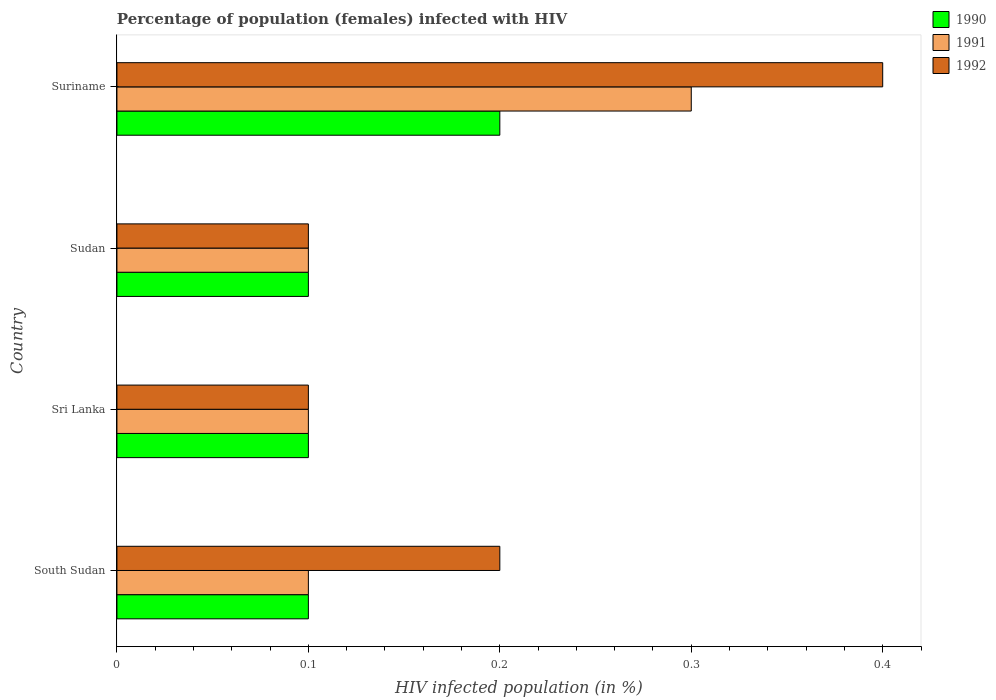Are the number of bars on each tick of the Y-axis equal?
Ensure brevity in your answer.  Yes. How many bars are there on the 2nd tick from the bottom?
Your answer should be very brief. 3. What is the label of the 3rd group of bars from the top?
Provide a short and direct response. Sri Lanka. In how many cases, is the number of bars for a given country not equal to the number of legend labels?
Ensure brevity in your answer.  0. Across all countries, what is the maximum percentage of HIV infected female population in 1991?
Offer a terse response. 0.3. In which country was the percentage of HIV infected female population in 1991 maximum?
Provide a short and direct response. Suriname. In which country was the percentage of HIV infected female population in 1992 minimum?
Keep it short and to the point. Sri Lanka. What is the total percentage of HIV infected female population in 1991 in the graph?
Your answer should be very brief. 0.6. What is the difference between the percentage of HIV infected female population in 1990 in Sri Lanka and the percentage of HIV infected female population in 1991 in Sudan?
Provide a succinct answer. 0. What is the difference between the highest and the second highest percentage of HIV infected female population in 1991?
Ensure brevity in your answer.  0.2. In how many countries, is the percentage of HIV infected female population in 1991 greater than the average percentage of HIV infected female population in 1991 taken over all countries?
Ensure brevity in your answer.  1. What does the 3rd bar from the top in South Sudan represents?
Ensure brevity in your answer.  1990. What does the 2nd bar from the bottom in South Sudan represents?
Ensure brevity in your answer.  1991. Are the values on the major ticks of X-axis written in scientific E-notation?
Offer a terse response. No. Does the graph contain any zero values?
Your answer should be compact. No. Where does the legend appear in the graph?
Offer a terse response. Top right. How many legend labels are there?
Offer a terse response. 3. What is the title of the graph?
Ensure brevity in your answer.  Percentage of population (females) infected with HIV. What is the label or title of the X-axis?
Make the answer very short. HIV infected population (in %). What is the label or title of the Y-axis?
Offer a terse response. Country. What is the HIV infected population (in %) of 1991 in South Sudan?
Your answer should be very brief. 0.1. What is the HIV infected population (in %) of 1992 in South Sudan?
Your response must be concise. 0.2. What is the HIV infected population (in %) in 1991 in Sri Lanka?
Keep it short and to the point. 0.1. What is the HIV infected population (in %) in 1990 in Sudan?
Keep it short and to the point. 0.1. What is the HIV infected population (in %) in 1991 in Sudan?
Provide a succinct answer. 0.1. What is the HIV infected population (in %) in 1992 in Sudan?
Offer a very short reply. 0.1. What is the HIV infected population (in %) in 1991 in Suriname?
Ensure brevity in your answer.  0.3. What is the HIV infected population (in %) of 1992 in Suriname?
Your response must be concise. 0.4. Across all countries, what is the maximum HIV infected population (in %) of 1992?
Keep it short and to the point. 0.4. Across all countries, what is the minimum HIV infected population (in %) in 1991?
Your answer should be very brief. 0.1. What is the total HIV infected population (in %) of 1990 in the graph?
Keep it short and to the point. 0.5. What is the total HIV infected population (in %) of 1992 in the graph?
Offer a terse response. 0.8. What is the difference between the HIV infected population (in %) of 1992 in South Sudan and that in Sri Lanka?
Offer a terse response. 0.1. What is the difference between the HIV infected population (in %) in 1990 in South Sudan and that in Sudan?
Your answer should be compact. 0. What is the difference between the HIV infected population (in %) of 1992 in South Sudan and that in Sudan?
Give a very brief answer. 0.1. What is the difference between the HIV infected population (in %) in 1990 in South Sudan and that in Suriname?
Make the answer very short. -0.1. What is the difference between the HIV infected population (in %) of 1990 in Sri Lanka and that in Sudan?
Provide a short and direct response. 0. What is the difference between the HIV infected population (in %) of 1992 in Sri Lanka and that in Sudan?
Your answer should be compact. 0. What is the difference between the HIV infected population (in %) in 1991 in Sri Lanka and that in Suriname?
Your answer should be very brief. -0.2. What is the difference between the HIV infected population (in %) in 1992 in Sri Lanka and that in Suriname?
Ensure brevity in your answer.  -0.3. What is the difference between the HIV infected population (in %) of 1990 in Sudan and that in Suriname?
Provide a succinct answer. -0.1. What is the difference between the HIV infected population (in %) of 1992 in Sudan and that in Suriname?
Offer a terse response. -0.3. What is the difference between the HIV infected population (in %) in 1990 in South Sudan and the HIV infected population (in %) in 1991 in Sudan?
Offer a terse response. 0. What is the difference between the HIV infected population (in %) of 1991 in South Sudan and the HIV infected population (in %) of 1992 in Sudan?
Give a very brief answer. 0. What is the difference between the HIV infected population (in %) of 1990 in South Sudan and the HIV infected population (in %) of 1991 in Suriname?
Provide a short and direct response. -0.2. What is the difference between the HIV infected population (in %) in 1990 in Sri Lanka and the HIV infected population (in %) in 1991 in Sudan?
Make the answer very short. 0. What is the difference between the HIV infected population (in %) of 1990 in Sri Lanka and the HIV infected population (in %) of 1992 in Sudan?
Provide a short and direct response. 0. What is the difference between the HIV infected population (in %) in 1991 in Sri Lanka and the HIV infected population (in %) in 1992 in Sudan?
Your answer should be compact. 0. What is the difference between the HIV infected population (in %) of 1990 in Sudan and the HIV infected population (in %) of 1991 in Suriname?
Your response must be concise. -0.2. What is the difference between the HIV infected population (in %) in 1990 in Sudan and the HIV infected population (in %) in 1992 in Suriname?
Your response must be concise. -0.3. What is the average HIV infected population (in %) in 1991 per country?
Keep it short and to the point. 0.15. What is the difference between the HIV infected population (in %) of 1990 and HIV infected population (in %) of 1991 in South Sudan?
Your response must be concise. 0. What is the difference between the HIV infected population (in %) in 1991 and HIV infected population (in %) in 1992 in South Sudan?
Offer a terse response. -0.1. What is the difference between the HIV infected population (in %) of 1991 and HIV infected population (in %) of 1992 in Sri Lanka?
Your answer should be very brief. 0. What is the difference between the HIV infected population (in %) in 1990 and HIV infected population (in %) in 1991 in Sudan?
Offer a very short reply. 0. What is the difference between the HIV infected population (in %) of 1990 and HIV infected population (in %) of 1992 in Sudan?
Ensure brevity in your answer.  0. What is the difference between the HIV infected population (in %) in 1990 and HIV infected population (in %) in 1991 in Suriname?
Provide a succinct answer. -0.1. What is the ratio of the HIV infected population (in %) of 1990 in South Sudan to that in Sri Lanka?
Your answer should be very brief. 1. What is the ratio of the HIV infected population (in %) of 1991 in South Sudan to that in Sri Lanka?
Provide a succinct answer. 1. What is the ratio of the HIV infected population (in %) of 1992 in South Sudan to that in Sri Lanka?
Your answer should be compact. 2. What is the ratio of the HIV infected population (in %) of 1990 in South Sudan to that in Sudan?
Your answer should be compact. 1. What is the ratio of the HIV infected population (in %) of 1991 in South Sudan to that in Sudan?
Make the answer very short. 1. What is the ratio of the HIV infected population (in %) in 1992 in South Sudan to that in Sudan?
Your answer should be compact. 2. What is the ratio of the HIV infected population (in %) in 1990 in Sri Lanka to that in Sudan?
Keep it short and to the point. 1. What is the ratio of the HIV infected population (in %) in 1992 in Sri Lanka to that in Sudan?
Give a very brief answer. 1. What is the ratio of the HIV infected population (in %) in 1991 in Sri Lanka to that in Suriname?
Offer a terse response. 0.33. What is the ratio of the HIV infected population (in %) of 1992 in Sri Lanka to that in Suriname?
Make the answer very short. 0.25. What is the ratio of the HIV infected population (in %) in 1990 in Sudan to that in Suriname?
Offer a very short reply. 0.5. What is the ratio of the HIV infected population (in %) of 1991 in Sudan to that in Suriname?
Provide a short and direct response. 0.33. What is the difference between the highest and the second highest HIV infected population (in %) in 1990?
Provide a succinct answer. 0.1. What is the difference between the highest and the second highest HIV infected population (in %) in 1992?
Keep it short and to the point. 0.2. 